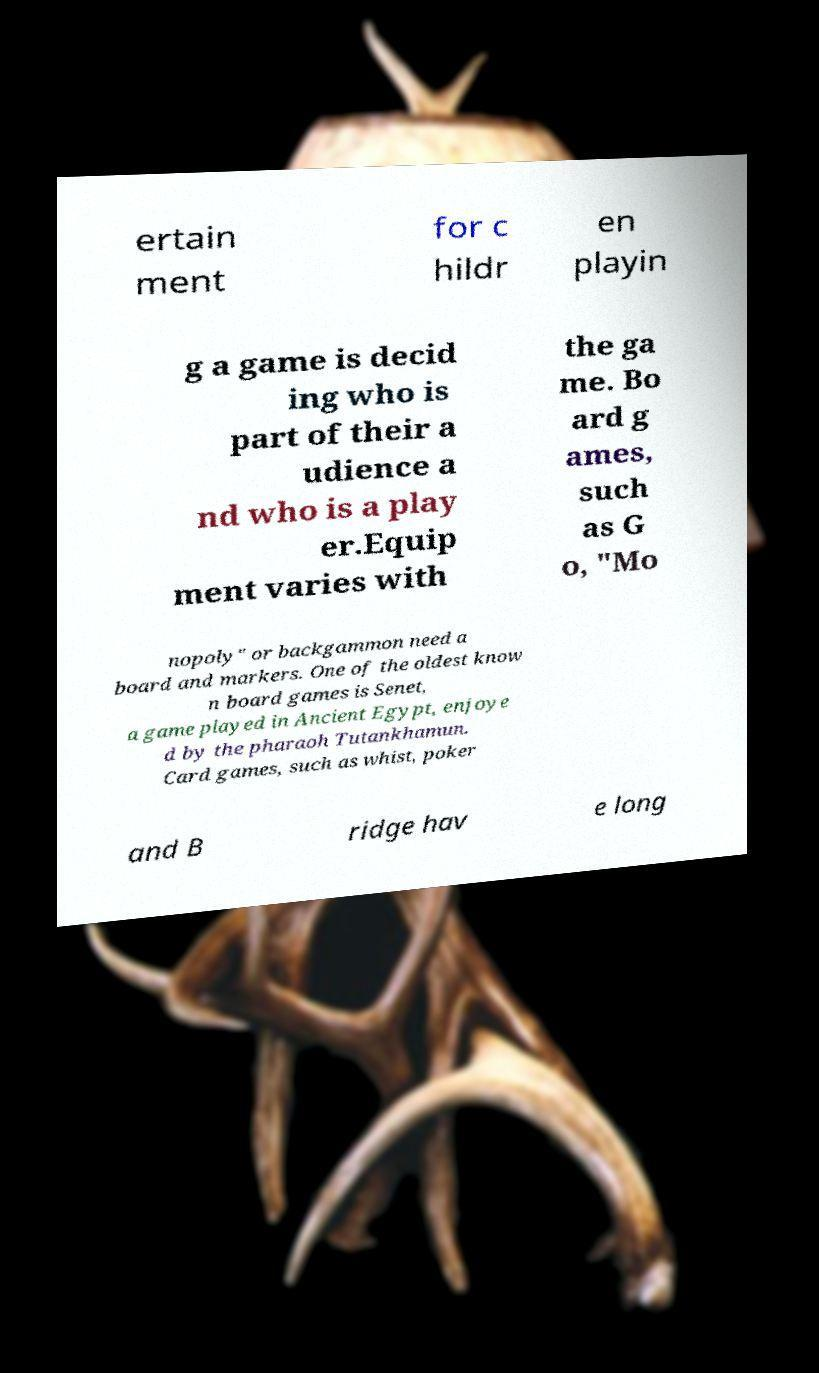There's text embedded in this image that I need extracted. Can you transcribe it verbatim? ertain ment for c hildr en playin g a game is decid ing who is part of their a udience a nd who is a play er.Equip ment varies with the ga me. Bo ard g ames, such as G o, "Mo nopoly" or backgammon need a board and markers. One of the oldest know n board games is Senet, a game played in Ancient Egypt, enjoye d by the pharaoh Tutankhamun. Card games, such as whist, poker and B ridge hav e long 